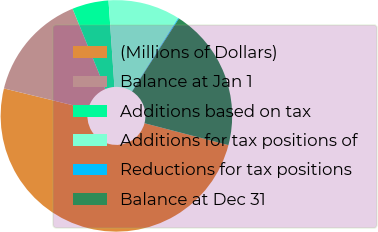<chart> <loc_0><loc_0><loc_500><loc_500><pie_chart><fcel>(Millions of Dollars)<fcel>Balance at Jan 1<fcel>Additions based on tax<fcel>Additions for tax positions of<fcel>Reductions for tax positions<fcel>Balance at Dec 31<nl><fcel>49.75%<fcel>15.01%<fcel>5.09%<fcel>10.05%<fcel>0.12%<fcel>19.98%<nl></chart> 